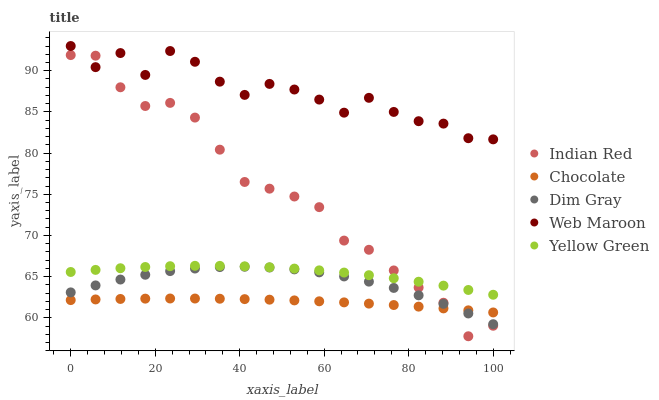Does Chocolate have the minimum area under the curve?
Answer yes or no. Yes. Does Web Maroon have the maximum area under the curve?
Answer yes or no. Yes. Does Yellow Green have the minimum area under the curve?
Answer yes or no. No. Does Yellow Green have the maximum area under the curve?
Answer yes or no. No. Is Chocolate the smoothest?
Answer yes or no. Yes. Is Web Maroon the roughest?
Answer yes or no. Yes. Is Yellow Green the smoothest?
Answer yes or no. No. Is Yellow Green the roughest?
Answer yes or no. No. Does Indian Red have the lowest value?
Answer yes or no. Yes. Does Yellow Green have the lowest value?
Answer yes or no. No. Does Web Maroon have the highest value?
Answer yes or no. Yes. Does Yellow Green have the highest value?
Answer yes or no. No. Is Yellow Green less than Web Maroon?
Answer yes or no. Yes. Is Web Maroon greater than Yellow Green?
Answer yes or no. Yes. Does Indian Red intersect Yellow Green?
Answer yes or no. Yes. Is Indian Red less than Yellow Green?
Answer yes or no. No. Is Indian Red greater than Yellow Green?
Answer yes or no. No. Does Yellow Green intersect Web Maroon?
Answer yes or no. No. 